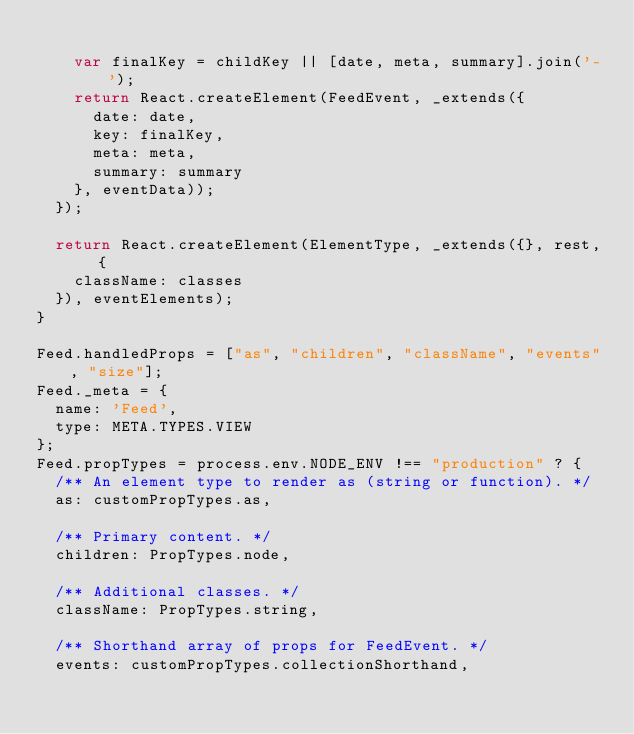Convert code to text. <code><loc_0><loc_0><loc_500><loc_500><_JavaScript_>
    var finalKey = childKey || [date, meta, summary].join('-');
    return React.createElement(FeedEvent, _extends({
      date: date,
      key: finalKey,
      meta: meta,
      summary: summary
    }, eventData));
  });

  return React.createElement(ElementType, _extends({}, rest, {
    className: classes
  }), eventElements);
}

Feed.handledProps = ["as", "children", "className", "events", "size"];
Feed._meta = {
  name: 'Feed',
  type: META.TYPES.VIEW
};
Feed.propTypes = process.env.NODE_ENV !== "production" ? {
  /** An element type to render as (string or function). */
  as: customPropTypes.as,

  /** Primary content. */
  children: PropTypes.node,

  /** Additional classes. */
  className: PropTypes.string,

  /** Shorthand array of props for FeedEvent. */
  events: customPropTypes.collectionShorthand,
</code> 